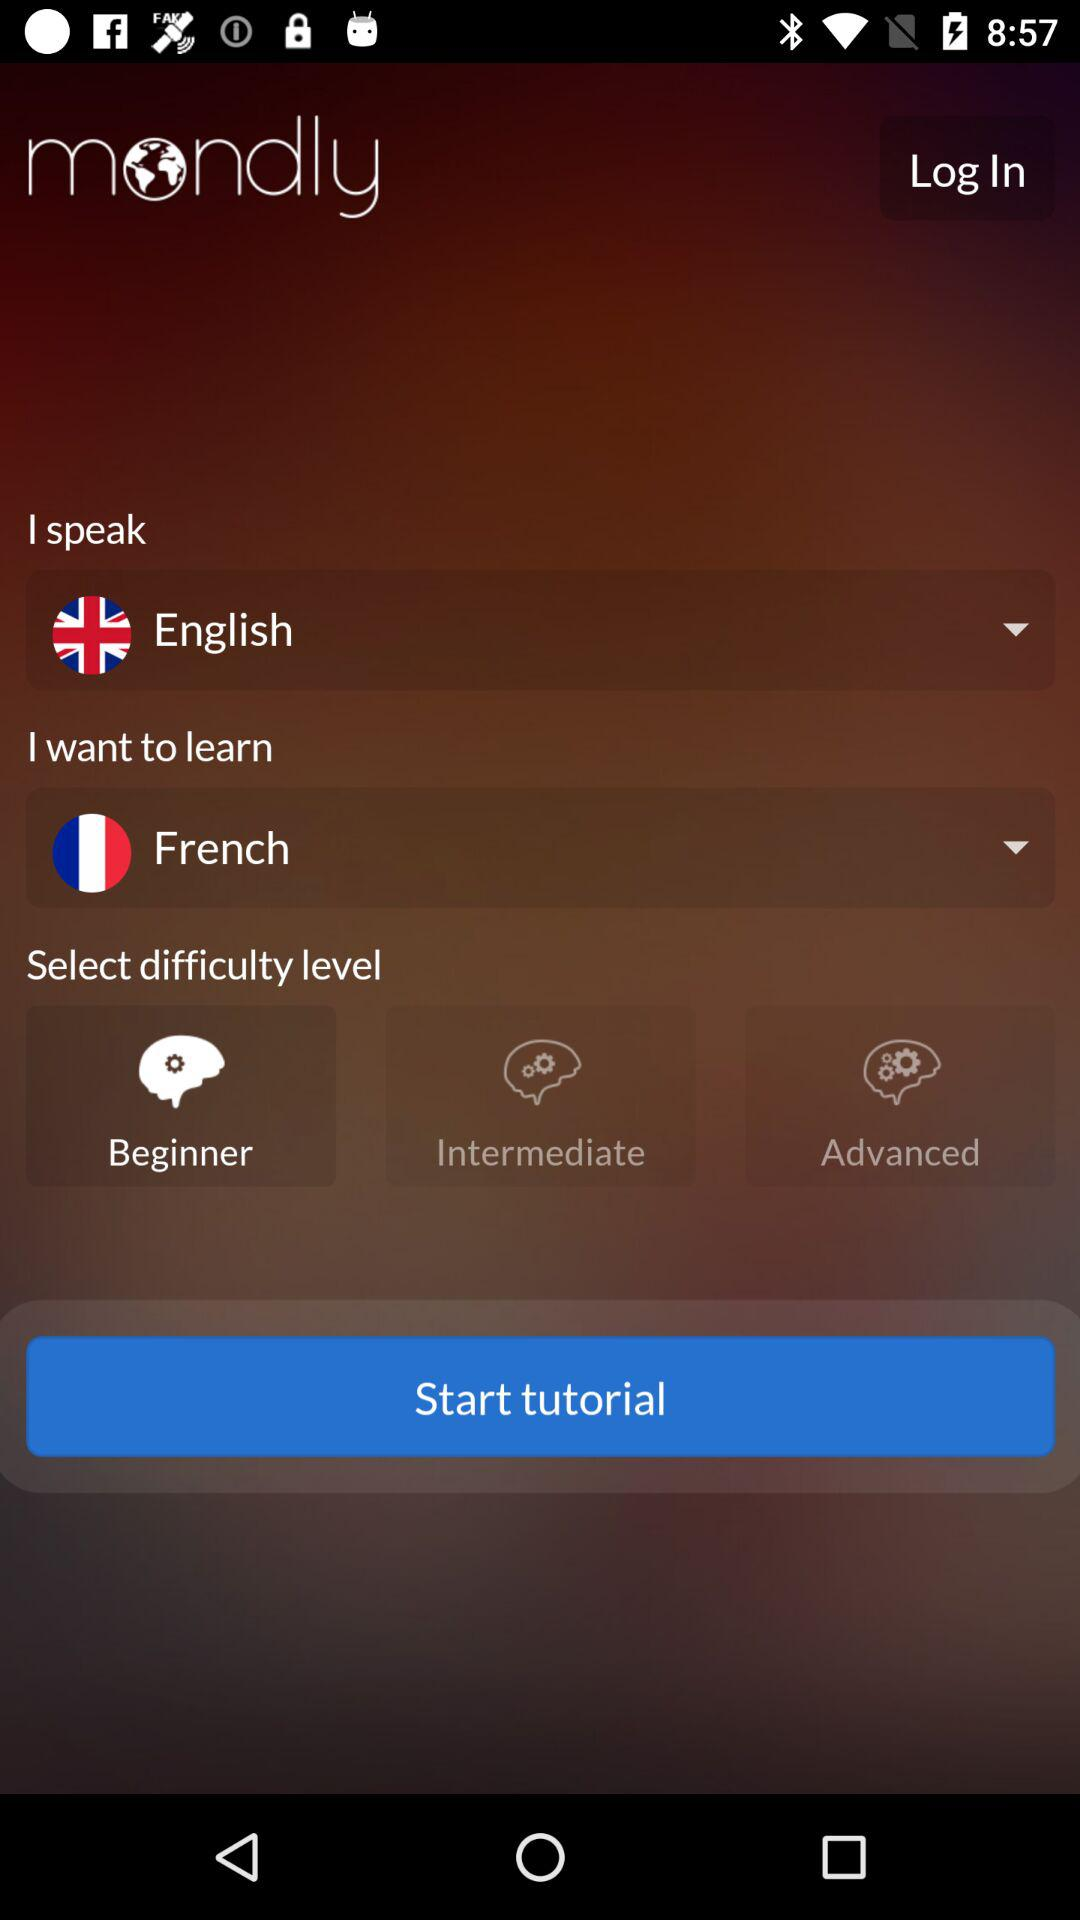How many difficulty levels are there?
Answer the question using a single word or phrase. 3 